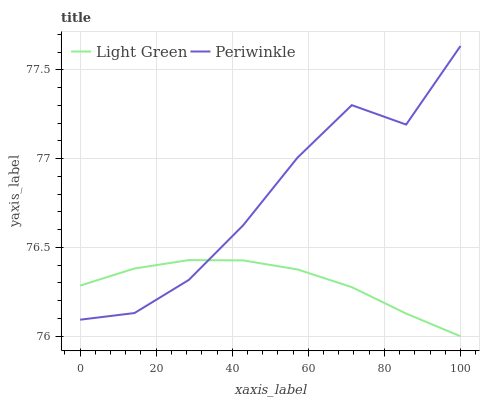Does Light Green have the minimum area under the curve?
Answer yes or no. Yes. Does Periwinkle have the maximum area under the curve?
Answer yes or no. Yes. Does Light Green have the maximum area under the curve?
Answer yes or no. No. Is Light Green the smoothest?
Answer yes or no. Yes. Is Periwinkle the roughest?
Answer yes or no. Yes. Is Light Green the roughest?
Answer yes or no. No. Does Light Green have the lowest value?
Answer yes or no. Yes. Does Periwinkle have the highest value?
Answer yes or no. Yes. Does Light Green have the highest value?
Answer yes or no. No. Does Periwinkle intersect Light Green?
Answer yes or no. Yes. Is Periwinkle less than Light Green?
Answer yes or no. No. Is Periwinkle greater than Light Green?
Answer yes or no. No. 